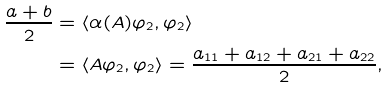Convert formula to latex. <formula><loc_0><loc_0><loc_500><loc_500>\frac { a + b } { 2 } & = \langle \alpha ( A ) \varphi _ { 2 } , \varphi _ { 2 } \rangle \\ & = \langle A \varphi _ { 2 } , \varphi _ { 2 } \rangle = \frac { a _ { 1 1 } + a _ { 1 2 } + a _ { 2 1 } + a _ { 2 2 } } { 2 } ,</formula> 